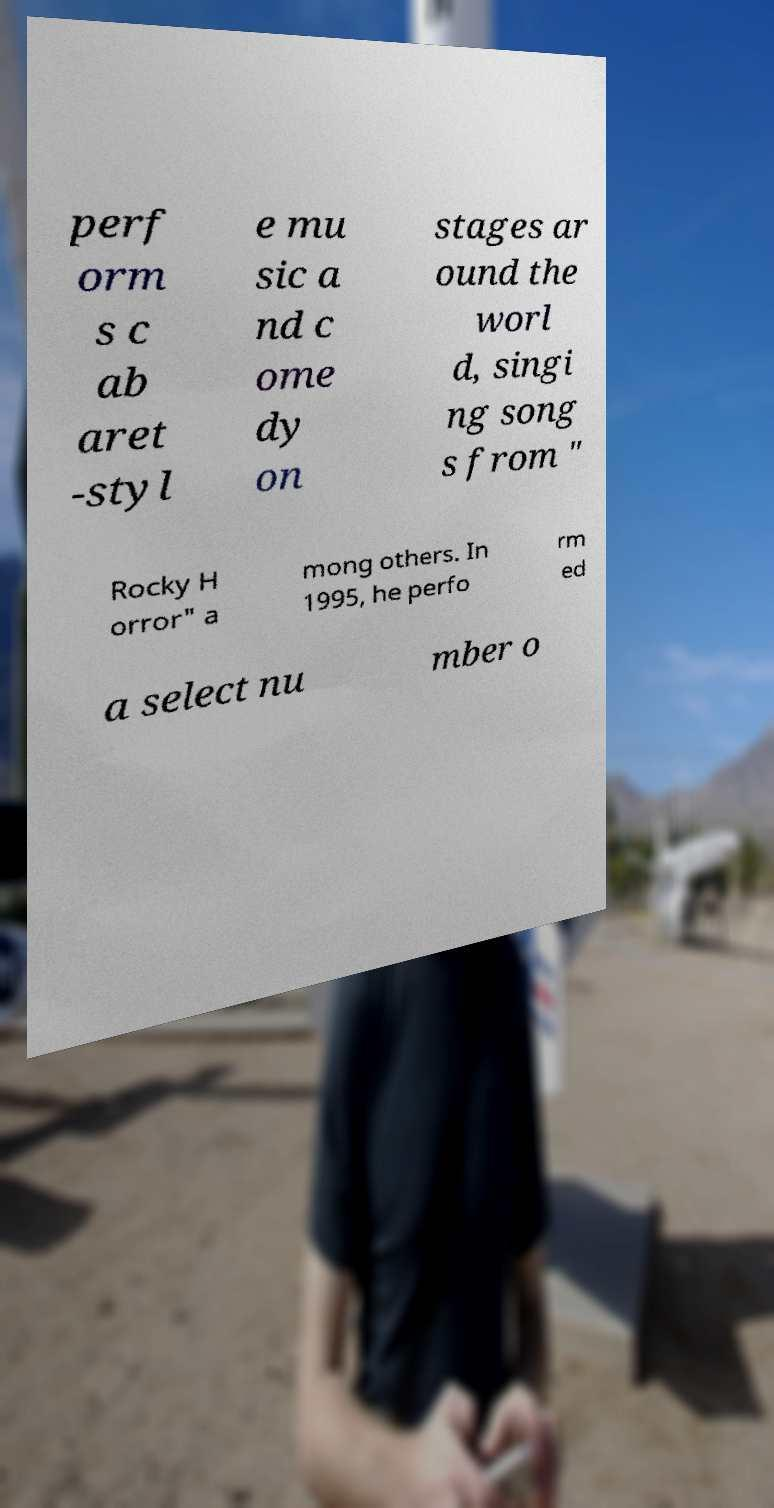Please identify and transcribe the text found in this image. perf orm s c ab aret -styl e mu sic a nd c ome dy on stages ar ound the worl d, singi ng song s from " Rocky H orror" a mong others. In 1995, he perfo rm ed a select nu mber o 